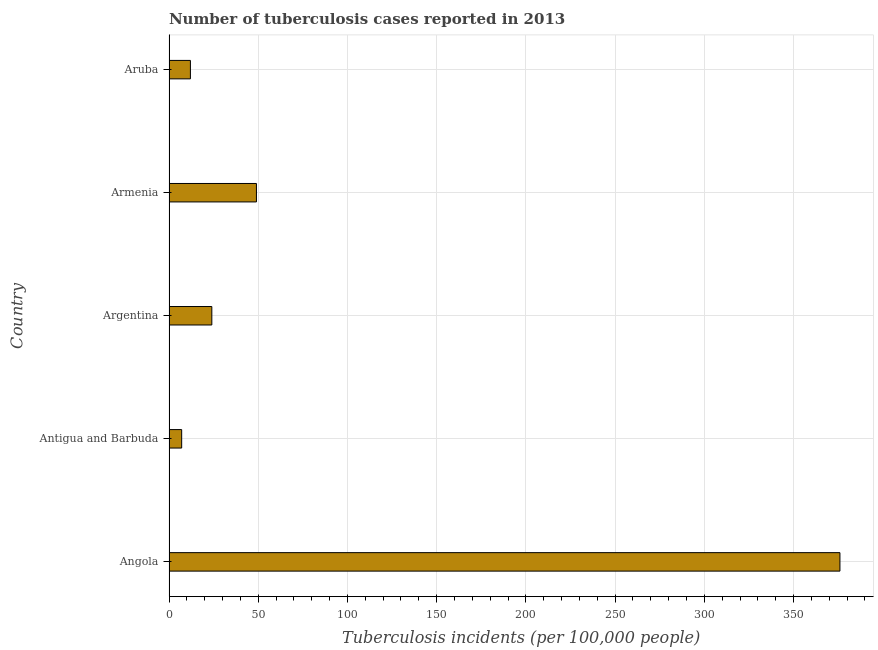Does the graph contain any zero values?
Provide a succinct answer. No. What is the title of the graph?
Give a very brief answer. Number of tuberculosis cases reported in 2013. What is the label or title of the X-axis?
Your response must be concise. Tuberculosis incidents (per 100,0 people). What is the label or title of the Y-axis?
Give a very brief answer. Country. What is the number of tuberculosis incidents in Antigua and Barbuda?
Your answer should be compact. 7.1. Across all countries, what is the maximum number of tuberculosis incidents?
Offer a very short reply. 376. In which country was the number of tuberculosis incidents maximum?
Give a very brief answer. Angola. In which country was the number of tuberculosis incidents minimum?
Provide a succinct answer. Antigua and Barbuda. What is the sum of the number of tuberculosis incidents?
Offer a terse response. 468.1. What is the difference between the number of tuberculosis incidents in Antigua and Barbuda and Armenia?
Make the answer very short. -41.9. What is the average number of tuberculosis incidents per country?
Ensure brevity in your answer.  93.62. What is the median number of tuberculosis incidents?
Provide a succinct answer. 24. What is the ratio of the number of tuberculosis incidents in Antigua and Barbuda to that in Aruba?
Ensure brevity in your answer.  0.59. Is the number of tuberculosis incidents in Argentina less than that in Aruba?
Your response must be concise. No. What is the difference between the highest and the second highest number of tuberculosis incidents?
Ensure brevity in your answer.  327. What is the difference between the highest and the lowest number of tuberculosis incidents?
Provide a short and direct response. 368.9. Are all the bars in the graph horizontal?
Your answer should be compact. Yes. How many countries are there in the graph?
Ensure brevity in your answer.  5. What is the difference between two consecutive major ticks on the X-axis?
Offer a very short reply. 50. Are the values on the major ticks of X-axis written in scientific E-notation?
Make the answer very short. No. What is the Tuberculosis incidents (per 100,000 people) of Angola?
Provide a succinct answer. 376. What is the Tuberculosis incidents (per 100,000 people) in Aruba?
Offer a terse response. 12. What is the difference between the Tuberculosis incidents (per 100,000 people) in Angola and Antigua and Barbuda?
Your response must be concise. 368.9. What is the difference between the Tuberculosis incidents (per 100,000 people) in Angola and Argentina?
Keep it short and to the point. 352. What is the difference between the Tuberculosis incidents (per 100,000 people) in Angola and Armenia?
Provide a short and direct response. 327. What is the difference between the Tuberculosis incidents (per 100,000 people) in Angola and Aruba?
Your response must be concise. 364. What is the difference between the Tuberculosis incidents (per 100,000 people) in Antigua and Barbuda and Argentina?
Give a very brief answer. -16.9. What is the difference between the Tuberculosis incidents (per 100,000 people) in Antigua and Barbuda and Armenia?
Ensure brevity in your answer.  -41.9. What is the difference between the Tuberculosis incidents (per 100,000 people) in Armenia and Aruba?
Your answer should be very brief. 37. What is the ratio of the Tuberculosis incidents (per 100,000 people) in Angola to that in Antigua and Barbuda?
Provide a succinct answer. 52.96. What is the ratio of the Tuberculosis incidents (per 100,000 people) in Angola to that in Argentina?
Your response must be concise. 15.67. What is the ratio of the Tuberculosis incidents (per 100,000 people) in Angola to that in Armenia?
Keep it short and to the point. 7.67. What is the ratio of the Tuberculosis incidents (per 100,000 people) in Angola to that in Aruba?
Provide a succinct answer. 31.33. What is the ratio of the Tuberculosis incidents (per 100,000 people) in Antigua and Barbuda to that in Argentina?
Keep it short and to the point. 0.3. What is the ratio of the Tuberculosis incidents (per 100,000 people) in Antigua and Barbuda to that in Armenia?
Your answer should be compact. 0.14. What is the ratio of the Tuberculosis incidents (per 100,000 people) in Antigua and Barbuda to that in Aruba?
Provide a short and direct response. 0.59. What is the ratio of the Tuberculosis incidents (per 100,000 people) in Argentina to that in Armenia?
Your response must be concise. 0.49. What is the ratio of the Tuberculosis incidents (per 100,000 people) in Argentina to that in Aruba?
Make the answer very short. 2. What is the ratio of the Tuberculosis incidents (per 100,000 people) in Armenia to that in Aruba?
Keep it short and to the point. 4.08. 